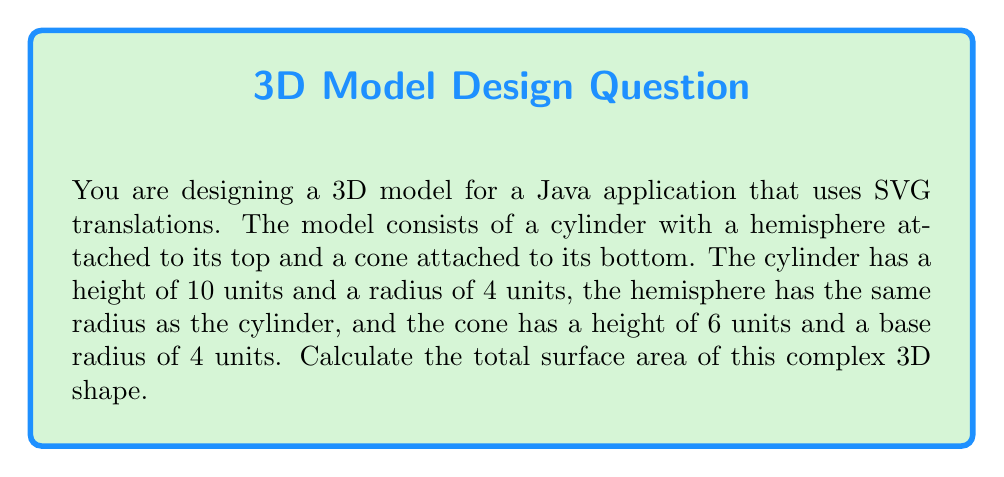Provide a solution to this math problem. To solve this problem, we need to break down the complex shape into its geometric primitives and calculate the surface area of each part separately. Then, we'll sum up these areas to get the total surface area.

1. Cylinder surface area:
   The surface area of a cylinder consists of two circular bases and the lateral area.
   $$A_{cylinder} = 2\pi r^2 + 2\pi rh$$
   where $r$ is the radius and $h$ is the height.
   $$A_{cylinder} = 2\pi(4^2) + 2\pi(4)(10) = 32\pi + 80\pi = 112\pi$$

2. Hemisphere surface area:
   We only need the curved surface area of the hemisphere, as its base is already accounted for in the cylinder.
   $$A_{hemisphere} = 2\pi r^2$$
   $$A_{hemisphere} = 2\pi(4^2) = 32\pi$$

3. Cone surface area:
   The surface area of a cone consists of the circular base and the lateral area.
   $$A_{cone} = \pi r^2 + \pi rs$$
   where $r$ is the radius of the base and $s$ is the slant height.
   We need to calculate the slant height using the Pythagorean theorem:
   $$s = \sqrt{r^2 + h^2} = \sqrt{4^2 + 6^2} = \sqrt{16 + 36} = \sqrt{52}$$
   Now we can calculate the cone's surface area:
   $$A_{cone} = \pi(4^2) + \pi(4)(\sqrt{52}) = 16\pi + 4\pi\sqrt{52}$$

Total surface area:
$$A_{total} = A_{cylinder} + A_{hemisphere} + A_{cone}$$
$$A_{total} = 112\pi + 32\pi + 16\pi + 4\pi\sqrt{52}$$
$$A_{total} = 160\pi + 4\pi\sqrt{52}$$

This can be simplified to:
$$A_{total} = 4\pi(40 + \sqrt{52})$$
Answer: $$4\pi(40 + \sqrt{52})$$ square units 